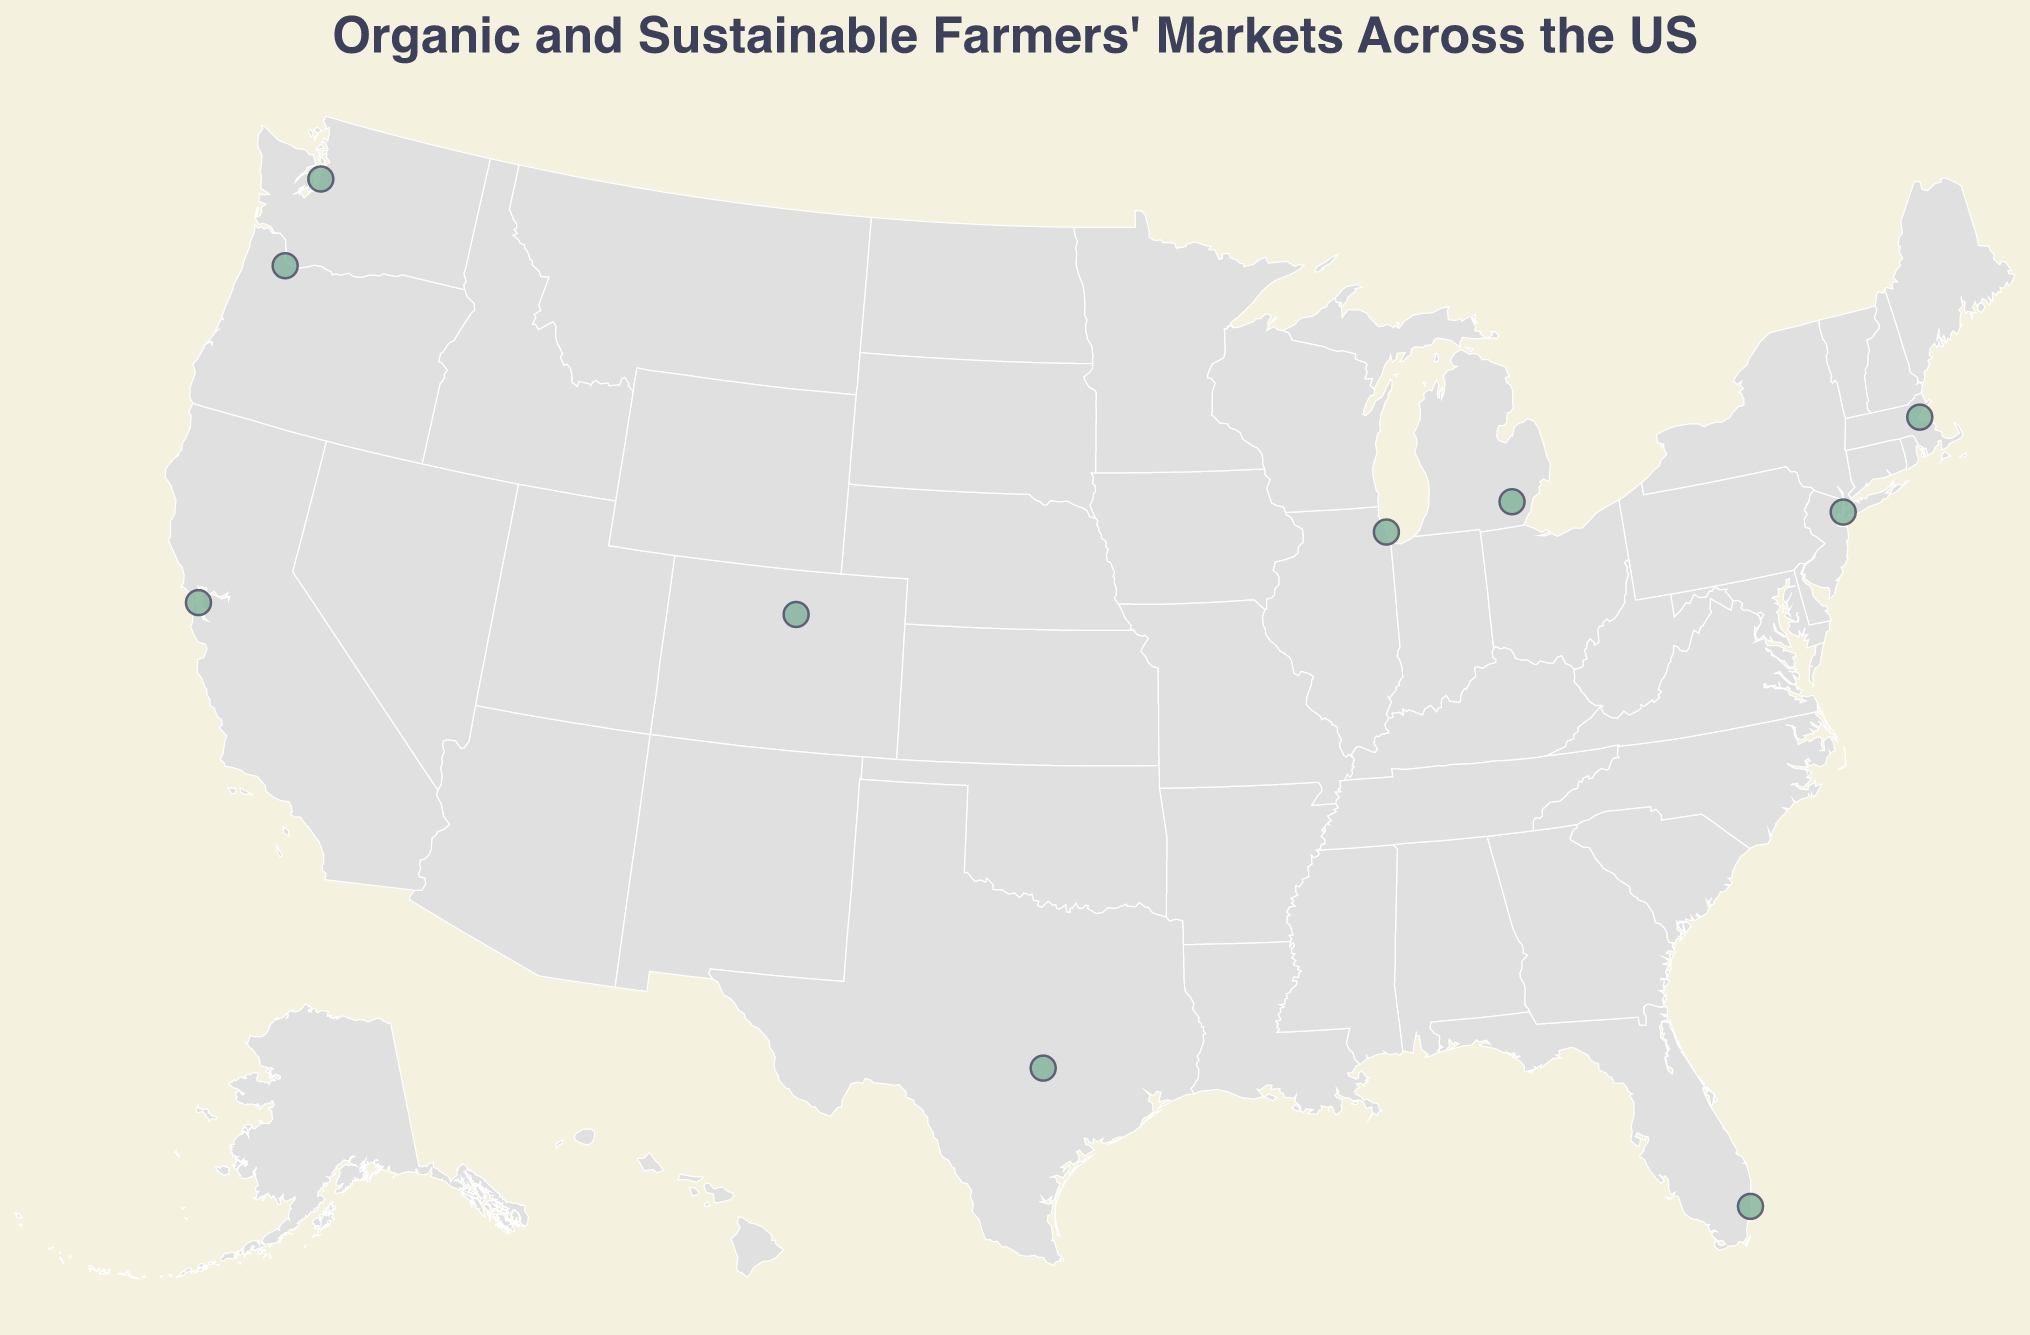Which state has the market with the name "Ferry Plaza Farmers Market"? The tooltip for each market shows the Market Name, City, State, and Specialty. The "Ferry Plaza Farmers Market" is in San Francisco, California.
Answer: California What is the main specialty offered by the Green City Market in Chicago? The tooltip information for each market contains details about the main specialty. For the Green City Market in Chicago, the specialty is "Heirloom Vegetables."
Answer: Heirloom Vegetables Which market is located the furthest north? By observing the latitude values, the market with the highest latitude is located furthest north. The Pike Place Market in Seattle has the highest latitude (47.6097).
Answer: Pike Place Market How many markets listed on the map are located on the West Coast of the United States? The West Coast typically includes California, Oregon, and Washington. By checking these states, there are three markets: Ferry Plaza Farmers Market, Portland Farmers Market, and Pike Place Market.
Answer: 3 Compare the specialties of the farmers markets located in New York and Massachusetts. How do they differ? Observing the tooltip for both New York City's Union Square Greenmarket and Boston's Boston Public Market, we find the specialties are "Artisanal Breads" and "Sustainable Seafood," respectively.
Answer: Artisanal Breads vs. Sustainable Seafood What is the average latitude of the farmers markets in California, Oregon, and Washington? Calculating the average latitude of the markets in these states: (37.7956 + 45.5189 + 47.6097) / 3 = 43.6414.
Answer: 43.6414 Which market offers “Farm-Fresh Eggs”? By referring to the Specialty information in the tooltips, we find that the SFC Farmers' Market Downtown in Austin, Texas offers “Farm-Fresh Eggs.”
Answer: SFC Farmers' Market Downtown Of the markets located in the Midwest (Illinois and Michigan), which one is closest to the geographic center of the United States? By comparing the longitude and latitude values of the Green City Market in Chicago and the Ann Arbor Farmers Market, the Ann Arbor Farmers Market (42.2808, -83.7430) is slightly closer to the geographic center based on its longitude being less negative.
Answer: Ann Arbor Farmers Market How many farmers markets have “Sustainable Seafood” as their specialty? Reviewing the Specialty tooltips reveals that only the Boston Public Market has "Sustainable Seafood" as its specialty.
Answer: 1 Is there any market on the map located below the latitude 30.0? If yes, name it. By examining the latitude values, only one market (Yellow Green Farmers Market in Miami, Florida) is located below the latitude 30.0 (25.9860).
Answer: Yellow Green Farmers Market 